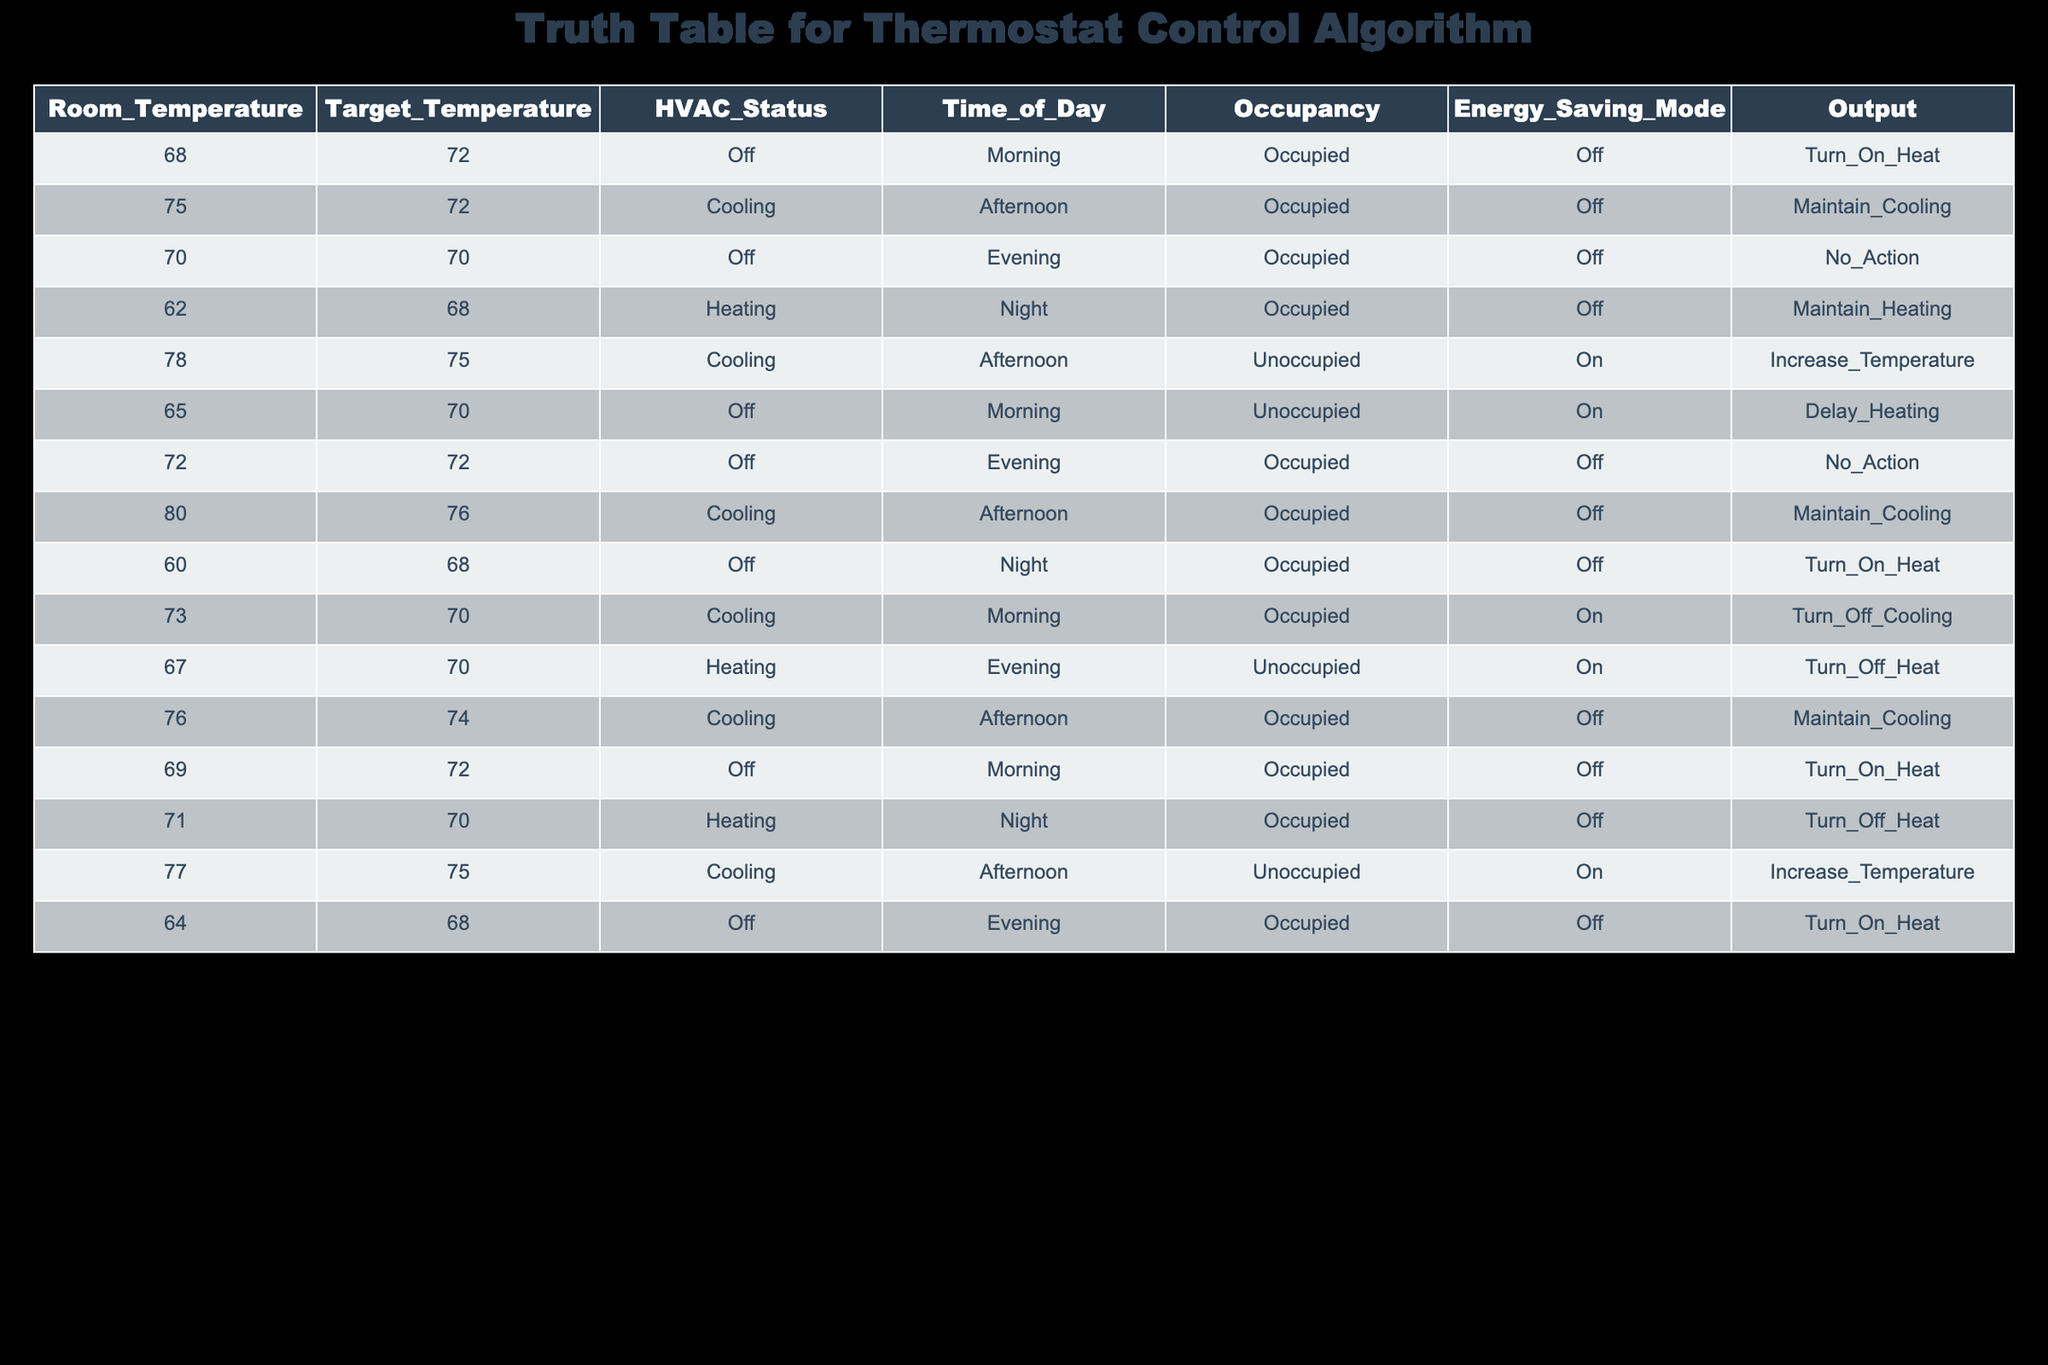What is the HVAC status when the room temperature is 78 degrees? Looking at the row with a room temperature of 78 degrees, it shows that the HVAC status is "Cooling."
Answer: Cooling How many times is the thermostat set to "Turn On Heat"? By scanning the output column, there are three instances where the output is "Turn On Heat": at room temperatures of 60, 64, and 69 degrees.
Answer: 3 What is the target temperature when the occupancy is "Occupied" and the energy-saving mode is on? There are two rows with occupancy set to "Occupied" and with energy-saving mode on; they have target temperatures of 70 and 70 degrees.
Answer: 70 Is the output "Increase Temperature" ever used when the room temperature exceeds the target temperature? In the table, "Increase Temperature" appears when the room temperature is 78 degrees with a target of 75 degrees, confirming that this output is used above the target temperature.
Answer: Yes What is the average room temperature during the morning when the HVAC status is "Off"? To find the average for the morning with HVAC status "Off," we identify the relevant rows (values are 68 and 69). The sum of these temperatures is 137. There are 2 rows, so the average is 137/2 = 68.5.
Answer: 68.5 What is the difference in the target temperature between the highest and lowest values in the table? The highest target temperature in the table is 76 degrees, and the lowest is 68 degrees. Calculating the difference gives us 76 - 68 = 8 degrees.
Answer: 8 Is there any instance where the energy-saving mode is "On" but the HVAC status is "Cooling"? Reviewing the table reveals that there is no instance where energy-saving mode is "On" and HVAC status is "Cooling." All relevant rows have either "Heating" or "Off."
Answer: No When is the output "Maintain Heating" active? The output "Maintain Heating" is active when the room temperature is 62 degrees, targeting 68 degrees during the night with occupancy "Occupied."
Answer: Night at 62 degrees 